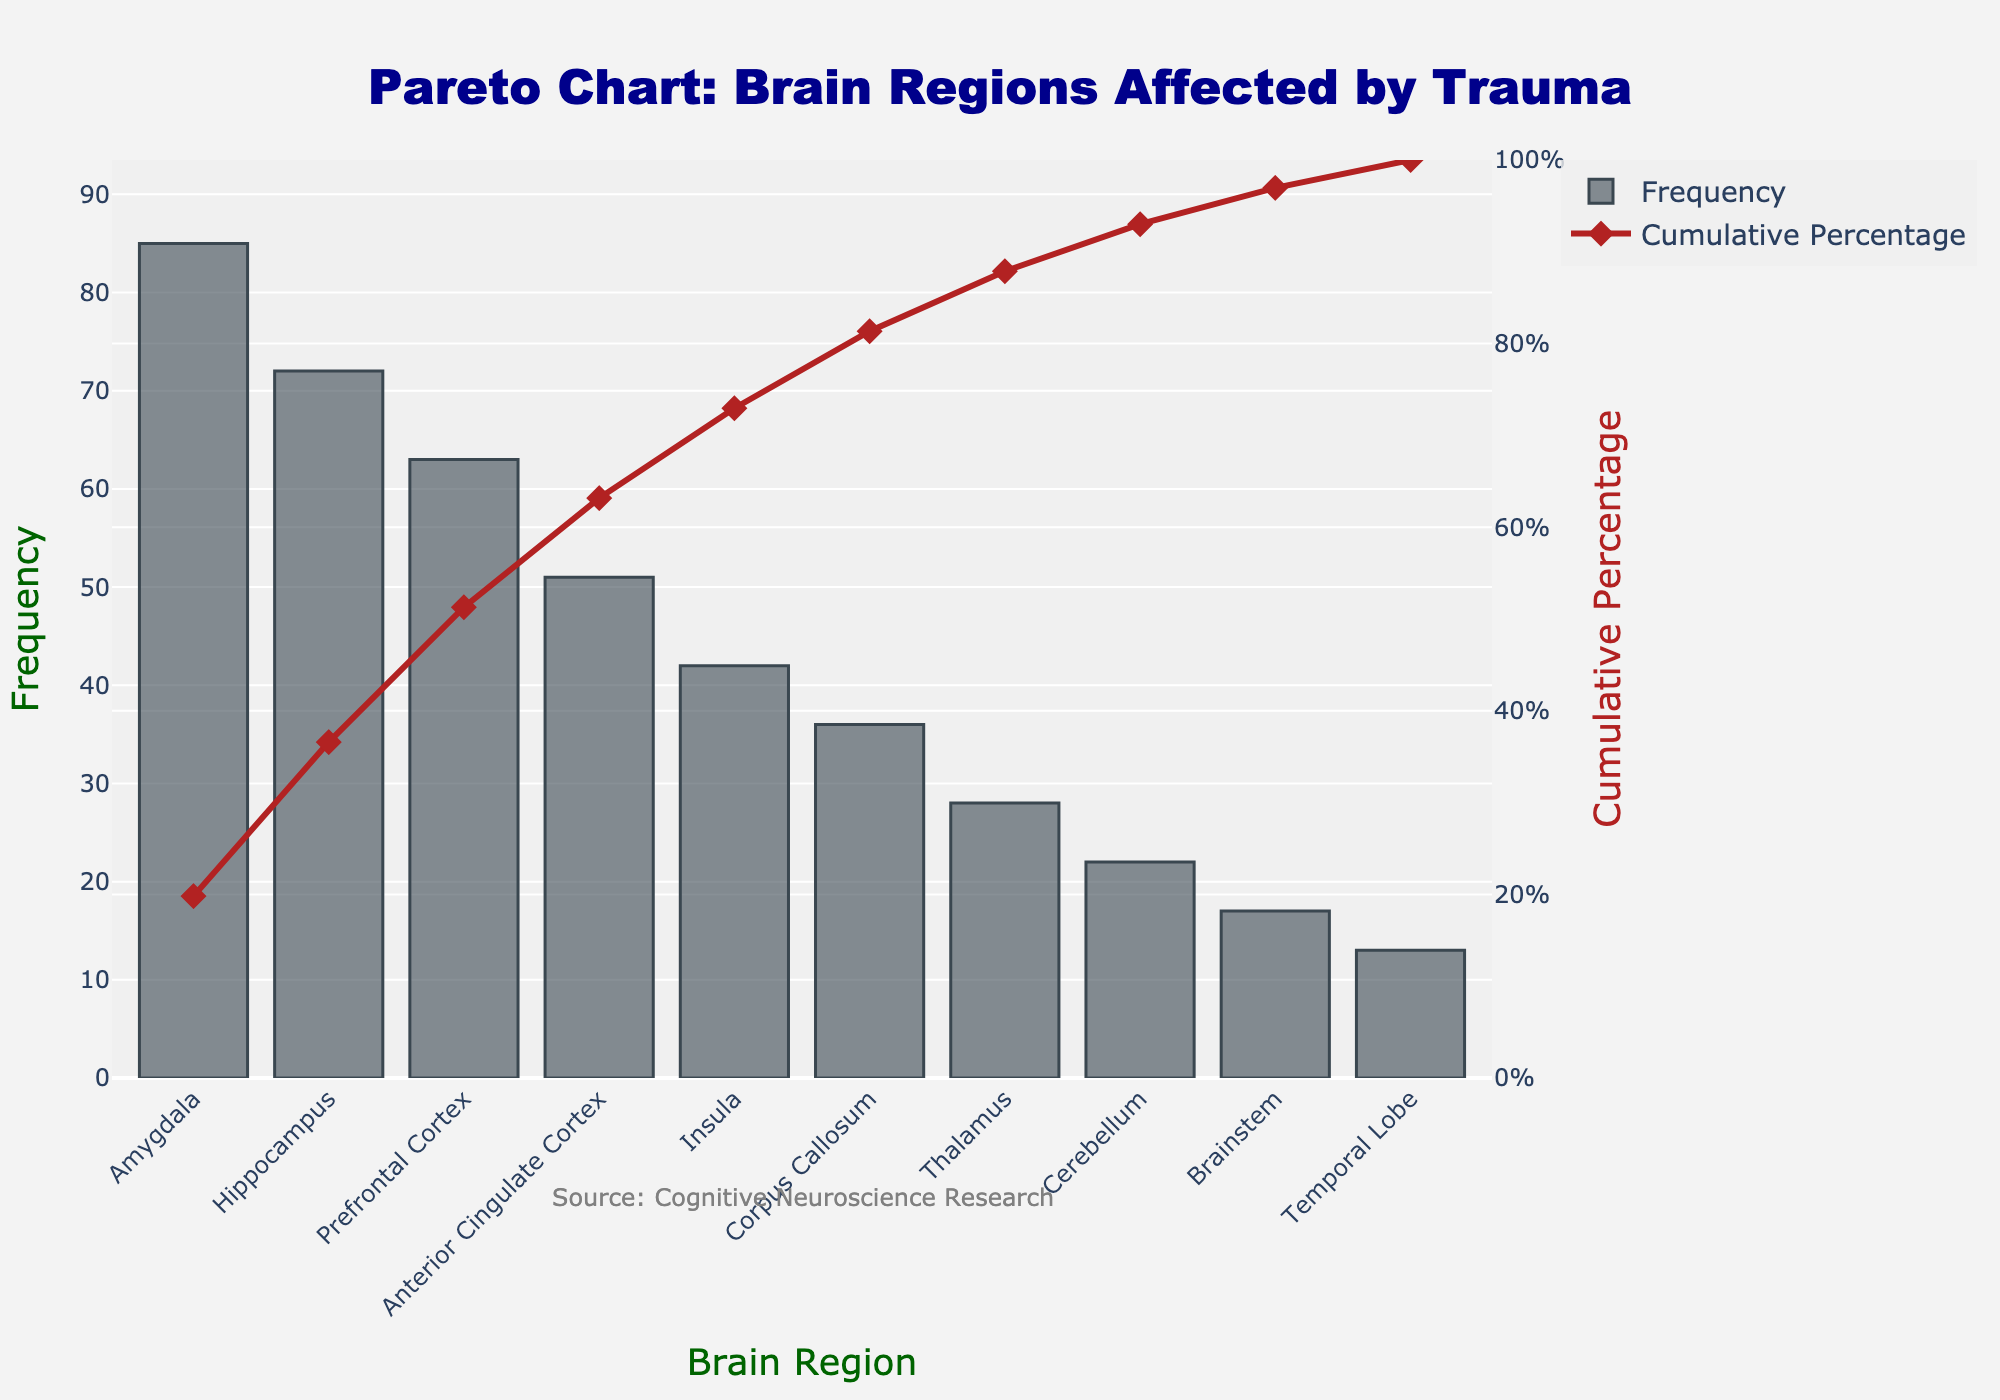Which brain region is most frequently affected by trauma? The chart shows the brain regions on the x-axis and their frequencies on the left y-axis. The highest bar corresponds to the most affected region.
Answer: Amygdala What is the cumulative percentage for the Prefrontal Cortex? Locate the data point for the Prefrontal Cortex on the x-axis and refer to the line chart corresponding to the right y-axis for cumulative percentage.
Answer: 71.4% How does the frequency of the Insula compare to that of the Corpus Callosum? Compare the height of the bars for the Insula and Corpus Callosum on the left y-axis. The Insula bar is higher than the Corpus Callosum bar.
Answer: The Insula has a higher frequency Which three brain regions contribute to over 50% of the cumulative percentage? Follow the cumulative percentage line on the right y-axis. The first three data points (Amygdala, Hippocampus, Prefrontal Cortex) have cumulative percentages summing to over 50%.
Answer: Amygdala, Hippocampus, Prefrontal Cortex How many brain regions have a frequency greater than 40? Count the bars that exceed the value of 40 on the frequency y-axis.
Answer: 4 By how much does the frequency of the Amygdala exceed that of the Thalamus? Subtract the frequency value of the Thalamus from that of the Amygdala: 85 - 28.
Answer: 57 What is the rank of the Corpus Callosum in terms of frequency? The ranks are determined based on the descending order of the bars. Count the position of the Corpus Callosum.
Answer: 6th What percentage of the cumulative total do the Amygdala and Hippocampus together account for? Add the cumulative percentage of the Hippocampus to that of the Amygdala: 45.7% + 39.7%.
Answer: 85.4% Which brain region has the lowest frequency of being affected by trauma? The smallest bar on the frequency y-axis corresponds to the lowest frequency.
Answer: Temporal Lobe 